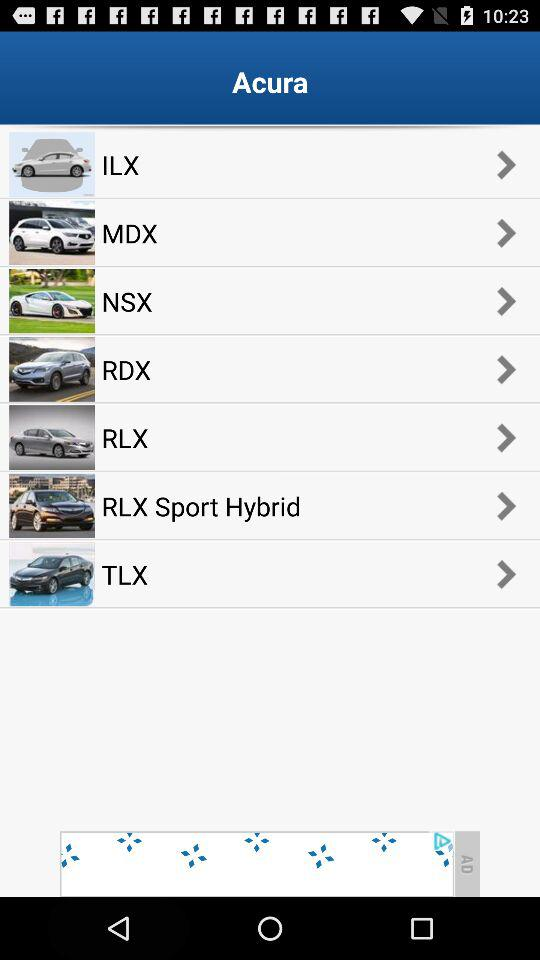Which are the different models of cars? The different models of cars are "ILX", "MDX", "NSX", "RDX", "RLX", "RLX Sport Hybrid" and "TLX". 